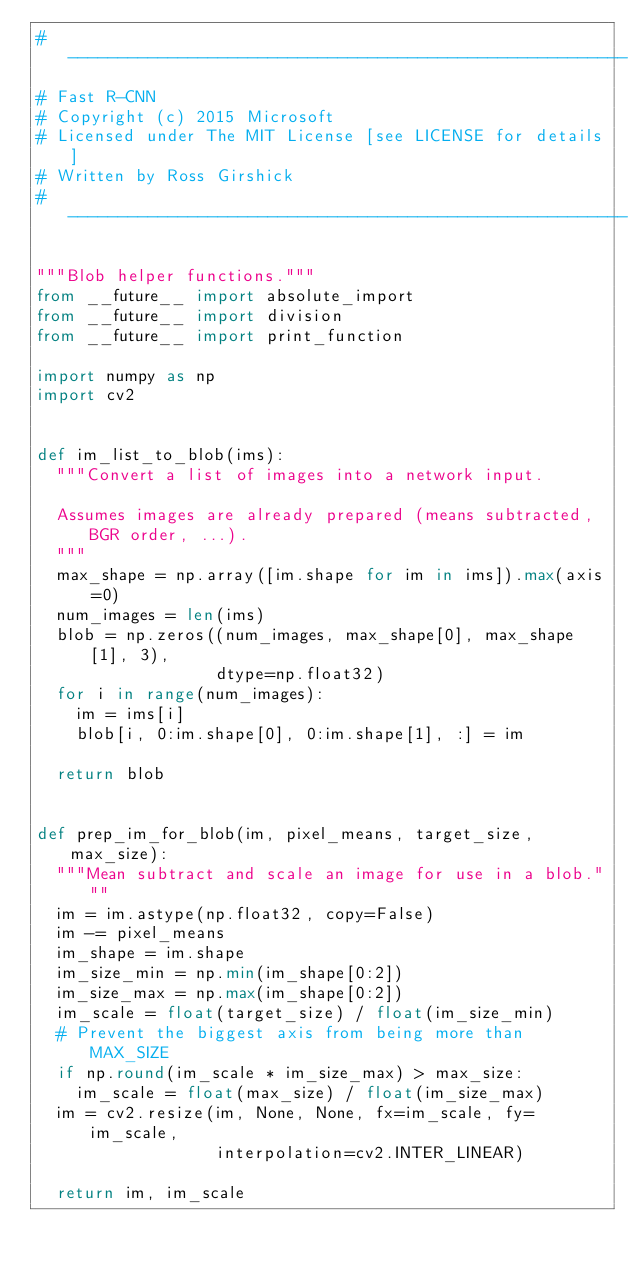<code> <loc_0><loc_0><loc_500><loc_500><_Python_># --------------------------------------------------------
# Fast R-CNN
# Copyright (c) 2015 Microsoft
# Licensed under The MIT License [see LICENSE for details]
# Written by Ross Girshick
# --------------------------------------------------------

"""Blob helper functions."""
from __future__ import absolute_import
from __future__ import division
from __future__ import print_function

import numpy as np
import cv2


def im_list_to_blob(ims):
  """Convert a list of images into a network input.

  Assumes images are already prepared (means subtracted, BGR order, ...).
  """
  max_shape = np.array([im.shape for im in ims]).max(axis=0)
  num_images = len(ims)
  blob = np.zeros((num_images, max_shape[0], max_shape[1], 3),
                  dtype=np.float32)
  for i in range(num_images):
    im = ims[i]
    blob[i, 0:im.shape[0], 0:im.shape[1], :] = im

  return blob


def prep_im_for_blob(im, pixel_means, target_size, max_size):
  """Mean subtract and scale an image for use in a blob."""
  im = im.astype(np.float32, copy=False)
  im -= pixel_means
  im_shape = im.shape
  im_size_min = np.min(im_shape[0:2])
  im_size_max = np.max(im_shape[0:2])
  im_scale = float(target_size) / float(im_size_min)
  # Prevent the biggest axis from being more than MAX_SIZE
  if np.round(im_scale * im_size_max) > max_size:
    im_scale = float(max_size) / float(im_size_max)
  im = cv2.resize(im, None, None, fx=im_scale, fy=im_scale,
                  interpolation=cv2.INTER_LINEAR)

  return im, im_scale
</code> 